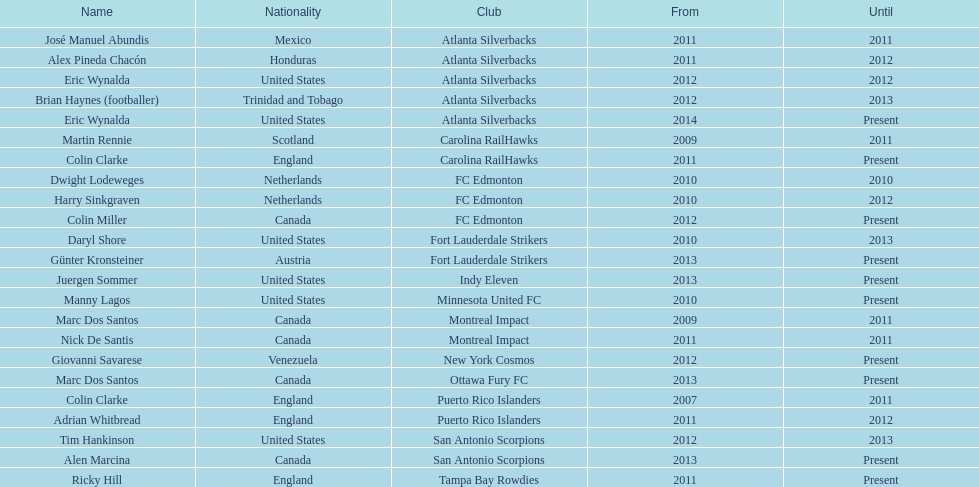In which year did marc dos santos and another coach both start their coaching careers? Martin Rennie. 